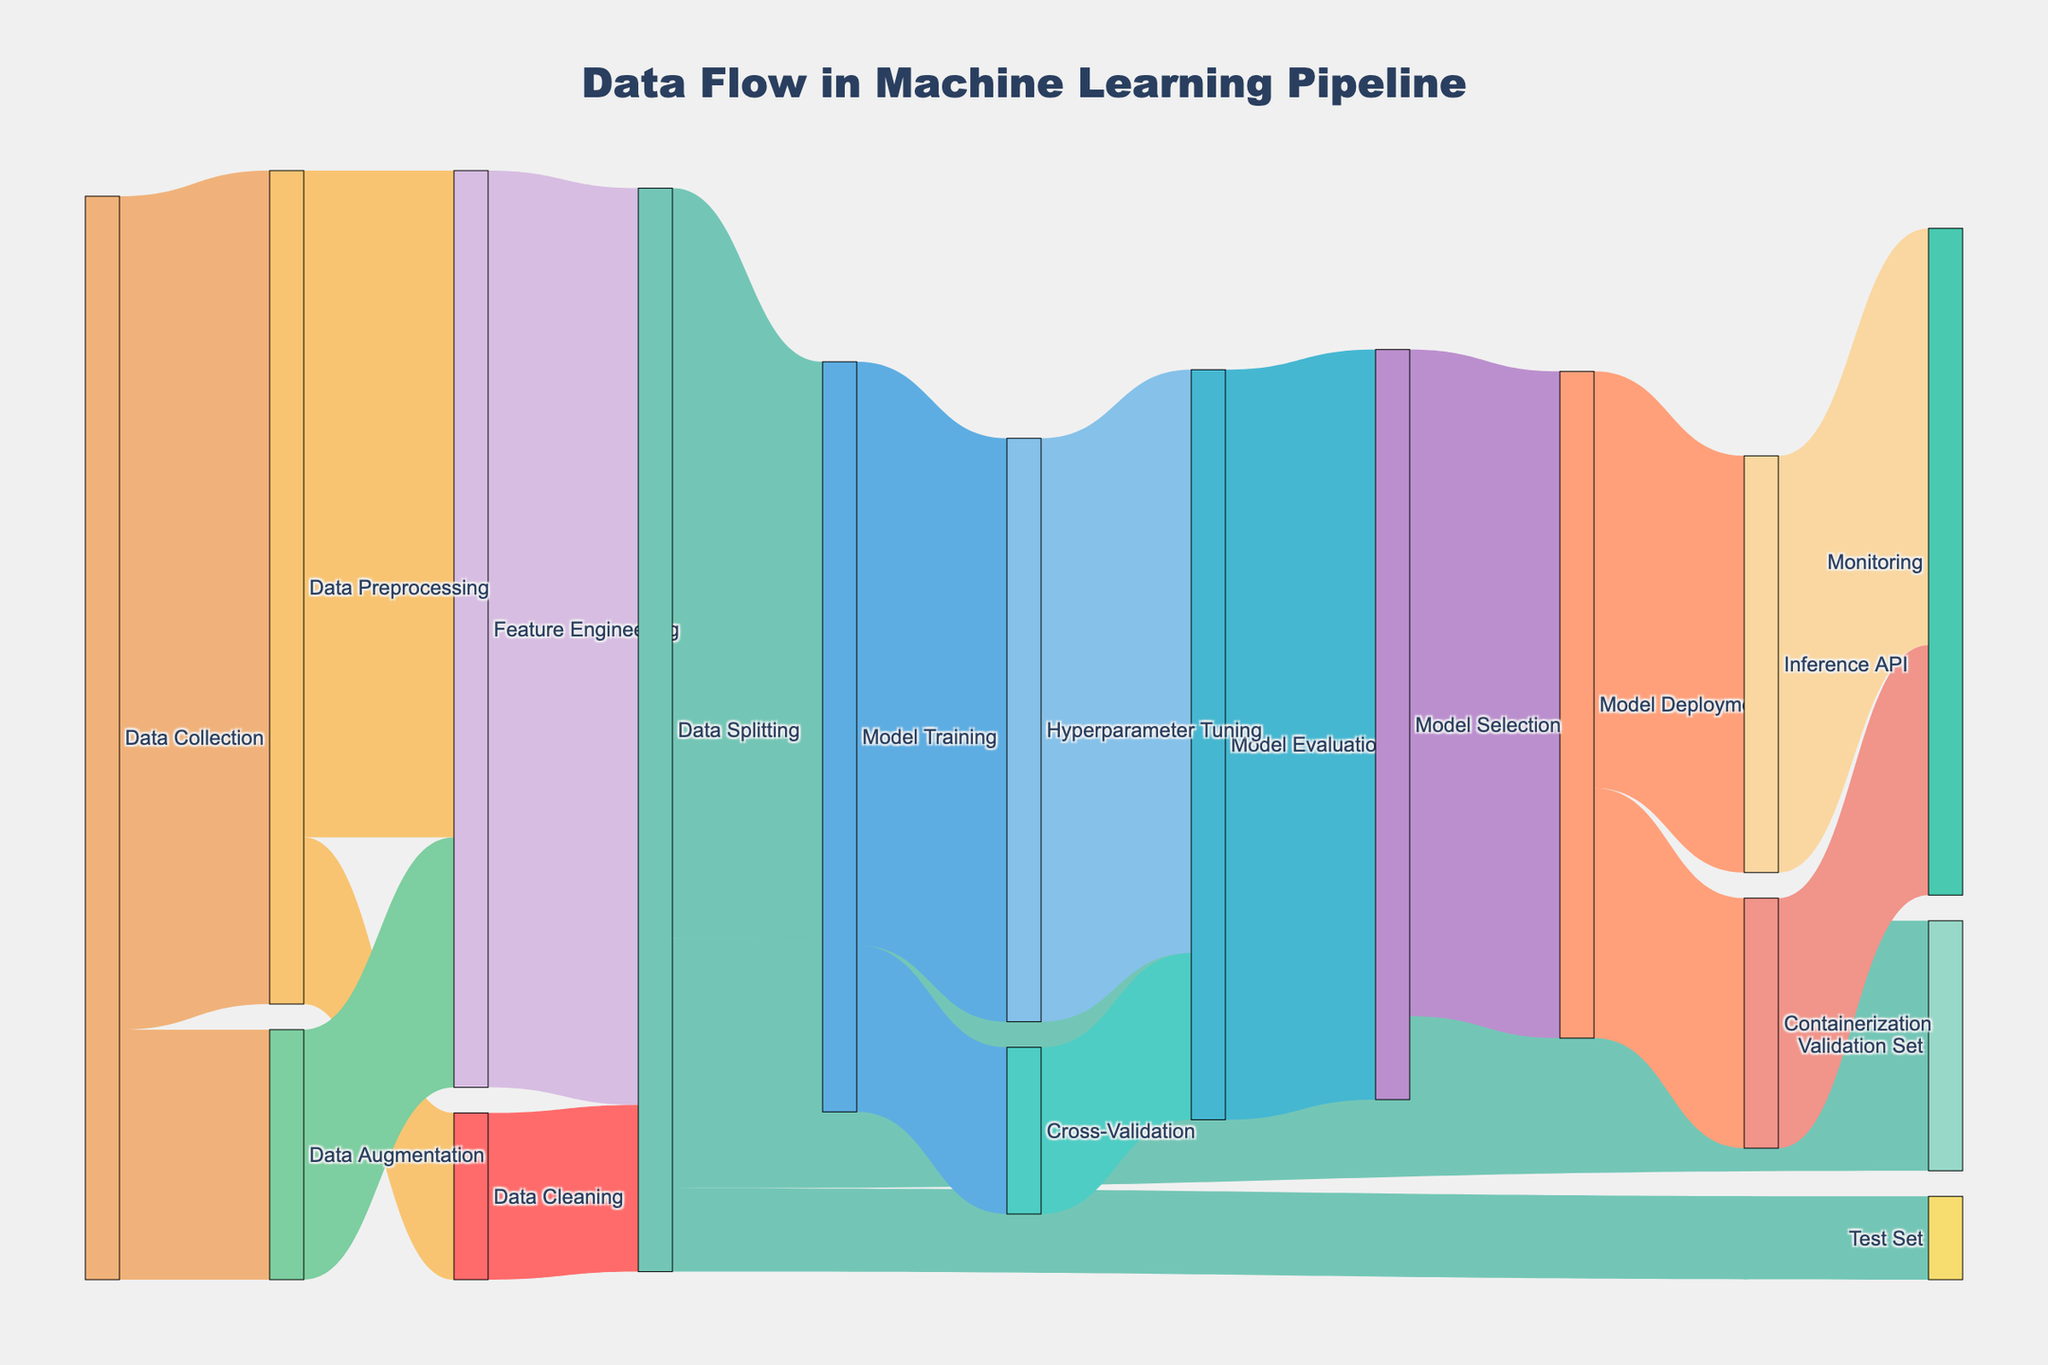How many steps are involved from Data Collection to Feature Engineering? There are three paths from Data Collection to Feature Engineering, sorted by links: Data Collection → Data Preprocessing → Feature Engineering, and Data Collection → Data Augmentation → Feature Engineering. This gives us two steps in each path.
Answer: 2 Which step sees the highest flow of data immediately after Data Splitting? After Data Splitting, there are three outgoing flows: Model Training (90), Validation Set (30), and Test Set (10). The highest flow is towards Model Training.
Answer: Model Training What is the total amount of data that goes into Model Evaluation? Model Evaluation receives data from Hyperparameter Tuning (70) and Cross-Validation (20). Summing these values gives 70 + 20 = 90.
Answer: 90 Does more data flow out from Model Selection lead to Model Deployment or elsewhere? Model Selection has one outgoing link leading to Model Deployment (80). There are no other outgoing paths from Model Selection.
Answer: Model Deployment How does the flow of data compare between Inference API and Containerization? Which receives more data? From Model Deployment, the flow is split into Inference API (50) and Containerization (30). Comparatively, Inference API receives more data.
Answer: Inference API What proportion of data goes through Hyperparameter Tuning during Model Training? Model Training flows into Hyperparameter Tuning with a value of 70 out of 90. The proportion is calculated as 70/90.
Answer: 70/90 What happens to the data after it's monitored? The data flow ends at Monitoring; there are no further outgoing connections from Monitoring.
Answer: Ends at Monitoring 